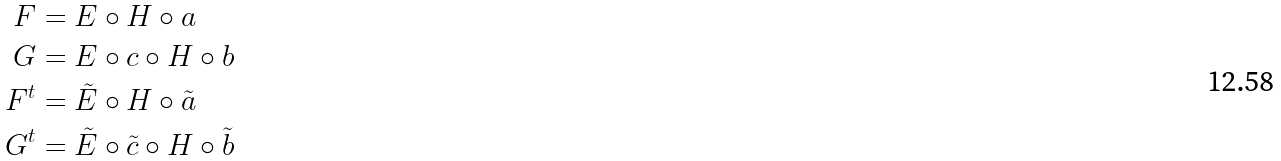Convert formula to latex. <formula><loc_0><loc_0><loc_500><loc_500>F & = E \circ H \circ a \\ G & = E \circ c \circ H \circ b \\ F ^ { t } & = \tilde { E } \circ H \circ \tilde { a } \\ G ^ { t } & = \tilde { E } \circ \tilde { c } \circ H \circ \tilde { b }</formula> 